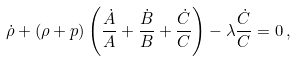Convert formula to latex. <formula><loc_0><loc_0><loc_500><loc_500>\dot { \rho } + ( \rho + p ) \left ( \frac { \dot { A } } { A } + \frac { \dot { B } } { B } + \frac { \dot { C } } { C } \right ) - \lambda \frac { \dot { C } } { C } = 0 \, ,</formula> 